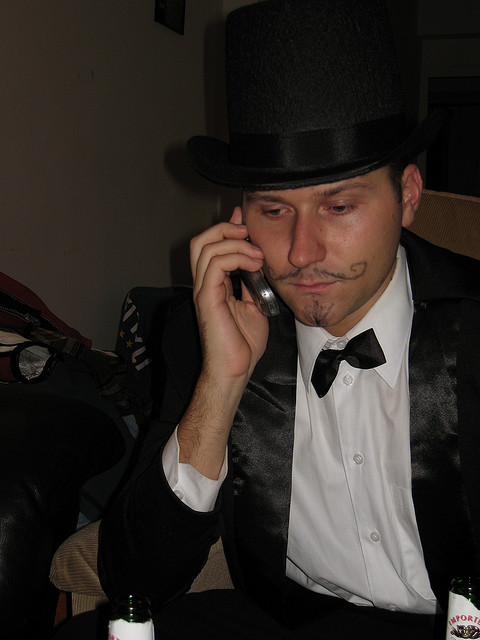What event might this person be attending based on his outfit? Given the man's formal attire complemented by a top hat and the whimsical addition of a drawn-on mustache, it's likely he could be attending a costume party, a fancy dress event, or celebrating a special occasion that calls for such playful yet formal attire, like a New Year's Eve gala. 